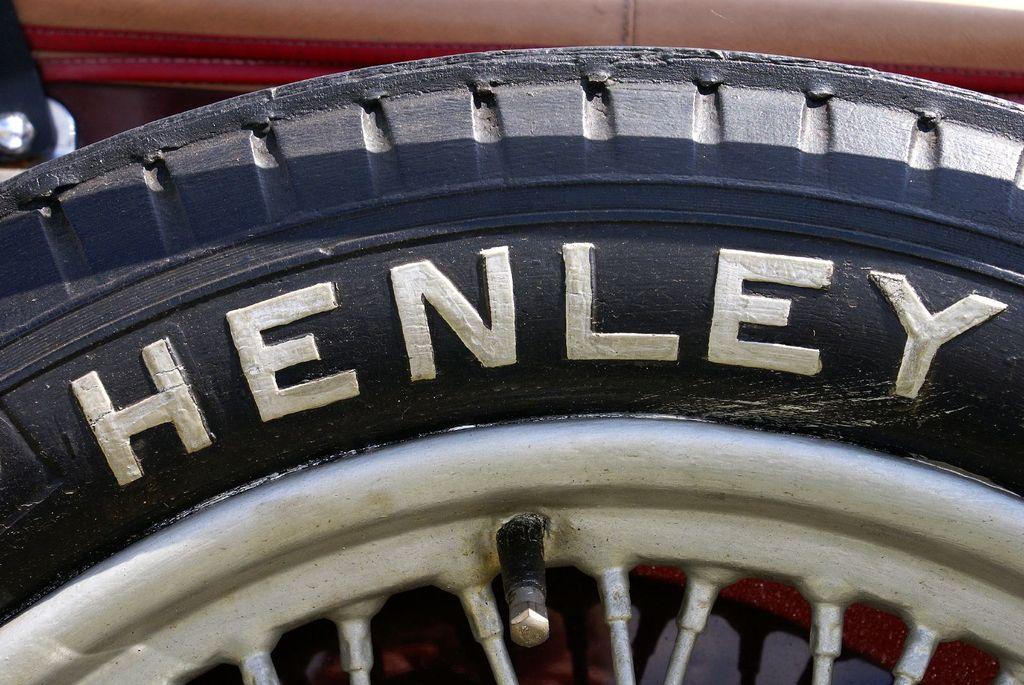In one or two sentences, can you explain what this image depicts? In the image we can see a vehicle tyre. 